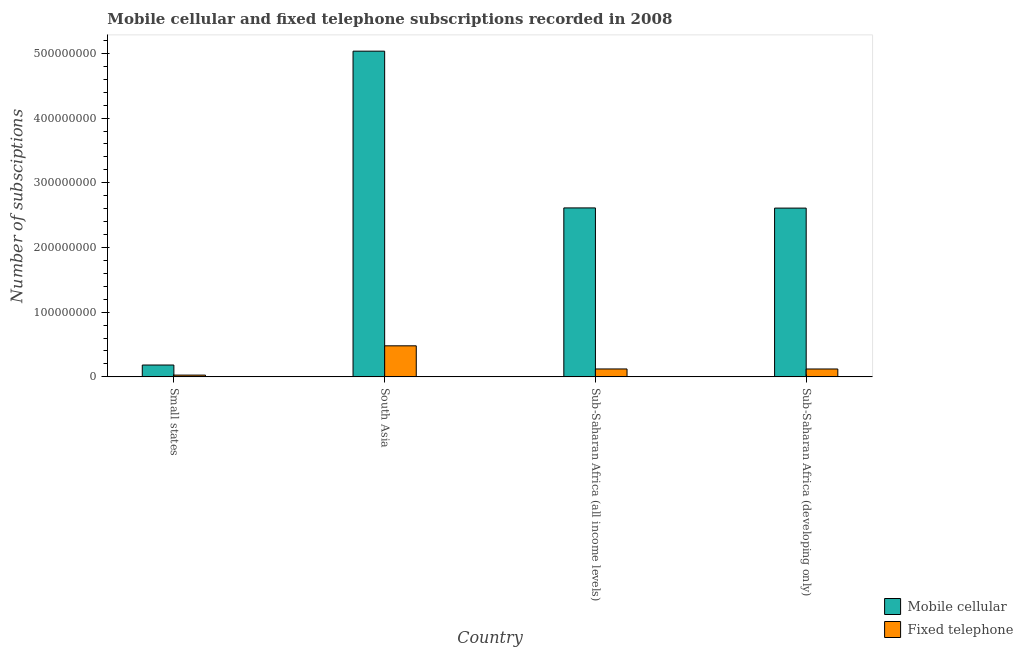Are the number of bars per tick equal to the number of legend labels?
Give a very brief answer. Yes. Are the number of bars on each tick of the X-axis equal?
Your answer should be very brief. Yes. How many bars are there on the 4th tick from the left?
Provide a short and direct response. 2. What is the label of the 1st group of bars from the left?
Ensure brevity in your answer.  Small states. What is the number of mobile cellular subscriptions in Sub-Saharan Africa (all income levels)?
Provide a short and direct response. 2.61e+08. Across all countries, what is the maximum number of fixed telephone subscriptions?
Provide a short and direct response. 4.80e+07. Across all countries, what is the minimum number of fixed telephone subscriptions?
Give a very brief answer. 2.75e+06. In which country was the number of mobile cellular subscriptions minimum?
Your answer should be very brief. Small states. What is the total number of mobile cellular subscriptions in the graph?
Provide a succinct answer. 1.04e+09. What is the difference between the number of fixed telephone subscriptions in Sub-Saharan Africa (all income levels) and that in Sub-Saharan Africa (developing only)?
Give a very brief answer. 3.23e+04. What is the difference between the number of mobile cellular subscriptions in Small states and the number of fixed telephone subscriptions in South Asia?
Provide a succinct answer. -2.97e+07. What is the average number of fixed telephone subscriptions per country?
Your response must be concise. 1.88e+07. What is the difference between the number of mobile cellular subscriptions and number of fixed telephone subscriptions in Small states?
Your answer should be very brief. 1.56e+07. In how many countries, is the number of mobile cellular subscriptions greater than 240000000 ?
Your response must be concise. 3. What is the ratio of the number of mobile cellular subscriptions in Small states to that in Sub-Saharan Africa (developing only)?
Make the answer very short. 0.07. What is the difference between the highest and the second highest number of mobile cellular subscriptions?
Provide a succinct answer. 2.42e+08. What is the difference between the highest and the lowest number of mobile cellular subscriptions?
Make the answer very short. 4.85e+08. In how many countries, is the number of fixed telephone subscriptions greater than the average number of fixed telephone subscriptions taken over all countries?
Give a very brief answer. 1. What does the 1st bar from the left in Sub-Saharan Africa (developing only) represents?
Your response must be concise. Mobile cellular. What does the 2nd bar from the right in Sub-Saharan Africa (developing only) represents?
Make the answer very short. Mobile cellular. Are all the bars in the graph horizontal?
Provide a short and direct response. No. How many countries are there in the graph?
Give a very brief answer. 4. Are the values on the major ticks of Y-axis written in scientific E-notation?
Make the answer very short. No. Does the graph contain grids?
Ensure brevity in your answer.  No. How are the legend labels stacked?
Offer a terse response. Vertical. What is the title of the graph?
Provide a succinct answer. Mobile cellular and fixed telephone subscriptions recorded in 2008. What is the label or title of the Y-axis?
Your answer should be compact. Number of subsciptions. What is the Number of subsciptions in Mobile cellular in Small states?
Keep it short and to the point. 1.83e+07. What is the Number of subsciptions of Fixed telephone in Small states?
Keep it short and to the point. 2.75e+06. What is the Number of subsciptions of Mobile cellular in South Asia?
Make the answer very short. 5.03e+08. What is the Number of subsciptions in Fixed telephone in South Asia?
Provide a succinct answer. 4.80e+07. What is the Number of subsciptions in Mobile cellular in Sub-Saharan Africa (all income levels)?
Make the answer very short. 2.61e+08. What is the Number of subsciptions of Fixed telephone in Sub-Saharan Africa (all income levels)?
Offer a terse response. 1.22e+07. What is the Number of subsciptions of Mobile cellular in Sub-Saharan Africa (developing only)?
Provide a short and direct response. 2.61e+08. What is the Number of subsciptions in Fixed telephone in Sub-Saharan Africa (developing only)?
Offer a terse response. 1.22e+07. Across all countries, what is the maximum Number of subsciptions of Mobile cellular?
Keep it short and to the point. 5.03e+08. Across all countries, what is the maximum Number of subsciptions of Fixed telephone?
Your answer should be compact. 4.80e+07. Across all countries, what is the minimum Number of subsciptions of Mobile cellular?
Make the answer very short. 1.83e+07. Across all countries, what is the minimum Number of subsciptions in Fixed telephone?
Your response must be concise. 2.75e+06. What is the total Number of subsciptions in Mobile cellular in the graph?
Your answer should be compact. 1.04e+09. What is the total Number of subsciptions of Fixed telephone in the graph?
Make the answer very short. 7.51e+07. What is the difference between the Number of subsciptions of Mobile cellular in Small states and that in South Asia?
Offer a very short reply. -4.85e+08. What is the difference between the Number of subsciptions in Fixed telephone in Small states and that in South Asia?
Your answer should be compact. -4.52e+07. What is the difference between the Number of subsciptions in Mobile cellular in Small states and that in Sub-Saharan Africa (all income levels)?
Provide a succinct answer. -2.43e+08. What is the difference between the Number of subsciptions of Fixed telephone in Small states and that in Sub-Saharan Africa (all income levels)?
Provide a succinct answer. -9.47e+06. What is the difference between the Number of subsciptions of Mobile cellular in Small states and that in Sub-Saharan Africa (developing only)?
Ensure brevity in your answer.  -2.43e+08. What is the difference between the Number of subsciptions of Fixed telephone in Small states and that in Sub-Saharan Africa (developing only)?
Your answer should be compact. -9.44e+06. What is the difference between the Number of subsciptions of Mobile cellular in South Asia and that in Sub-Saharan Africa (all income levels)?
Keep it short and to the point. 2.42e+08. What is the difference between the Number of subsciptions of Fixed telephone in South Asia and that in Sub-Saharan Africa (all income levels)?
Provide a succinct answer. 3.58e+07. What is the difference between the Number of subsciptions in Mobile cellular in South Asia and that in Sub-Saharan Africa (developing only)?
Provide a short and direct response. 2.43e+08. What is the difference between the Number of subsciptions in Fixed telephone in South Asia and that in Sub-Saharan Africa (developing only)?
Provide a short and direct response. 3.58e+07. What is the difference between the Number of subsciptions in Mobile cellular in Sub-Saharan Africa (all income levels) and that in Sub-Saharan Africa (developing only)?
Provide a succinct answer. 2.73e+05. What is the difference between the Number of subsciptions of Fixed telephone in Sub-Saharan Africa (all income levels) and that in Sub-Saharan Africa (developing only)?
Make the answer very short. 3.23e+04. What is the difference between the Number of subsciptions in Mobile cellular in Small states and the Number of subsciptions in Fixed telephone in South Asia?
Offer a very short reply. -2.97e+07. What is the difference between the Number of subsciptions in Mobile cellular in Small states and the Number of subsciptions in Fixed telephone in Sub-Saharan Africa (all income levels)?
Provide a succinct answer. 6.09e+06. What is the difference between the Number of subsciptions in Mobile cellular in Small states and the Number of subsciptions in Fixed telephone in Sub-Saharan Africa (developing only)?
Your answer should be very brief. 6.12e+06. What is the difference between the Number of subsciptions in Mobile cellular in South Asia and the Number of subsciptions in Fixed telephone in Sub-Saharan Africa (all income levels)?
Make the answer very short. 4.91e+08. What is the difference between the Number of subsciptions in Mobile cellular in South Asia and the Number of subsciptions in Fixed telephone in Sub-Saharan Africa (developing only)?
Your answer should be very brief. 4.91e+08. What is the difference between the Number of subsciptions of Mobile cellular in Sub-Saharan Africa (all income levels) and the Number of subsciptions of Fixed telephone in Sub-Saharan Africa (developing only)?
Keep it short and to the point. 2.49e+08. What is the average Number of subsciptions in Mobile cellular per country?
Your answer should be very brief. 2.61e+08. What is the average Number of subsciptions of Fixed telephone per country?
Give a very brief answer. 1.88e+07. What is the difference between the Number of subsciptions in Mobile cellular and Number of subsciptions in Fixed telephone in Small states?
Your answer should be very brief. 1.56e+07. What is the difference between the Number of subsciptions of Mobile cellular and Number of subsciptions of Fixed telephone in South Asia?
Make the answer very short. 4.55e+08. What is the difference between the Number of subsciptions in Mobile cellular and Number of subsciptions in Fixed telephone in Sub-Saharan Africa (all income levels)?
Ensure brevity in your answer.  2.49e+08. What is the difference between the Number of subsciptions of Mobile cellular and Number of subsciptions of Fixed telephone in Sub-Saharan Africa (developing only)?
Provide a short and direct response. 2.49e+08. What is the ratio of the Number of subsciptions in Mobile cellular in Small states to that in South Asia?
Offer a terse response. 0.04. What is the ratio of the Number of subsciptions in Fixed telephone in Small states to that in South Asia?
Offer a very short reply. 0.06. What is the ratio of the Number of subsciptions in Mobile cellular in Small states to that in Sub-Saharan Africa (all income levels)?
Your response must be concise. 0.07. What is the ratio of the Number of subsciptions of Fixed telephone in Small states to that in Sub-Saharan Africa (all income levels)?
Give a very brief answer. 0.22. What is the ratio of the Number of subsciptions in Mobile cellular in Small states to that in Sub-Saharan Africa (developing only)?
Offer a very short reply. 0.07. What is the ratio of the Number of subsciptions in Fixed telephone in Small states to that in Sub-Saharan Africa (developing only)?
Keep it short and to the point. 0.23. What is the ratio of the Number of subsciptions in Mobile cellular in South Asia to that in Sub-Saharan Africa (all income levels)?
Your answer should be very brief. 1.93. What is the ratio of the Number of subsciptions in Fixed telephone in South Asia to that in Sub-Saharan Africa (all income levels)?
Your answer should be compact. 3.93. What is the ratio of the Number of subsciptions in Mobile cellular in South Asia to that in Sub-Saharan Africa (developing only)?
Offer a terse response. 1.93. What is the ratio of the Number of subsciptions in Fixed telephone in South Asia to that in Sub-Saharan Africa (developing only)?
Give a very brief answer. 3.94. What is the difference between the highest and the second highest Number of subsciptions of Mobile cellular?
Keep it short and to the point. 2.42e+08. What is the difference between the highest and the second highest Number of subsciptions of Fixed telephone?
Provide a succinct answer. 3.58e+07. What is the difference between the highest and the lowest Number of subsciptions of Mobile cellular?
Ensure brevity in your answer.  4.85e+08. What is the difference between the highest and the lowest Number of subsciptions in Fixed telephone?
Your answer should be compact. 4.52e+07. 